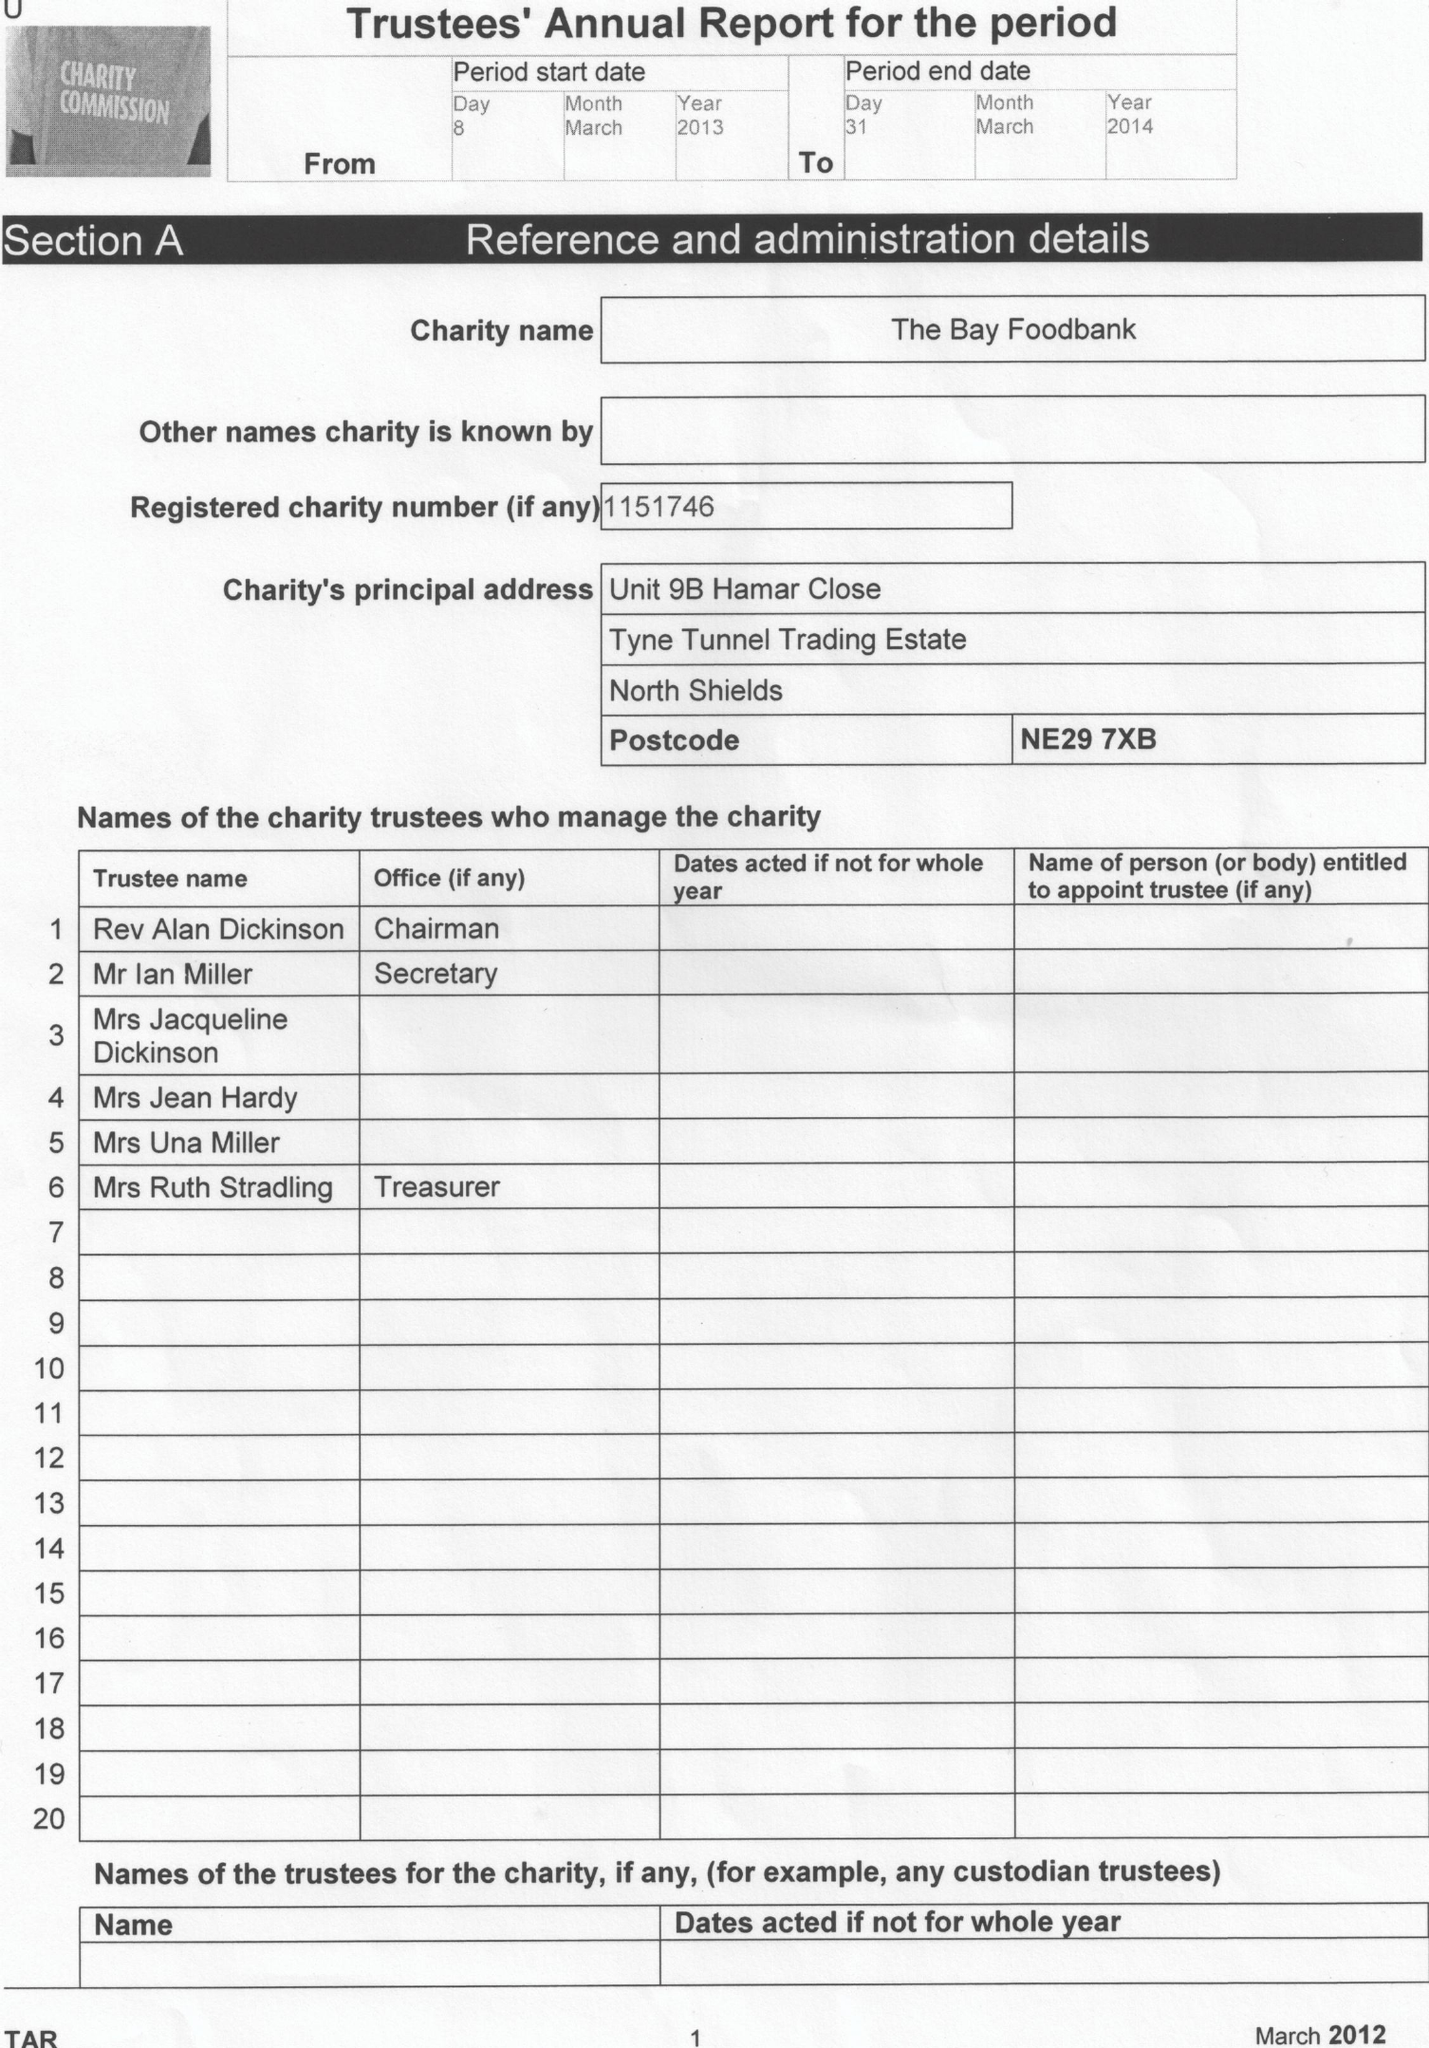What is the value for the address__postcode?
Answer the question using a single word or phrase. NE29 7XB 